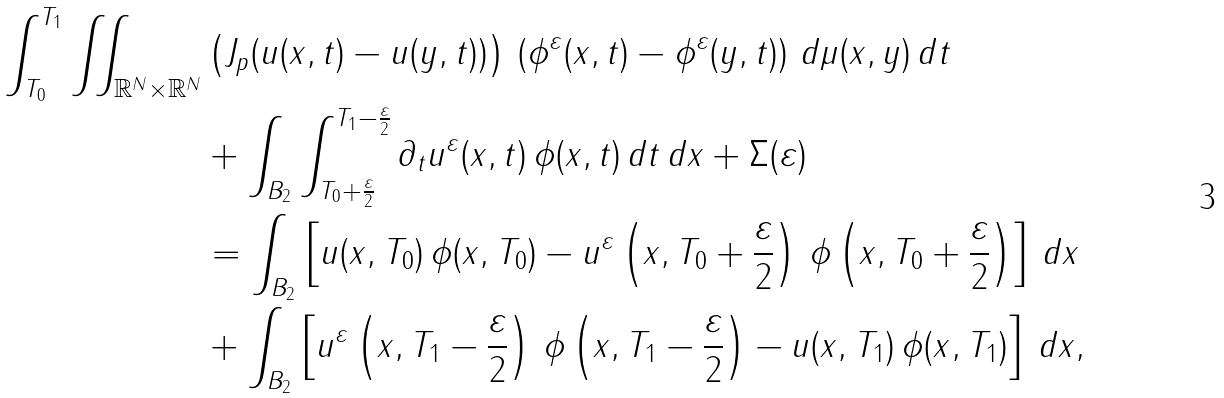<formula> <loc_0><loc_0><loc_500><loc_500>\int _ { T _ { 0 } } ^ { T _ { 1 } } \iint _ { \mathbb { R } ^ { N } \times \mathbb { R } ^ { N } } & \left ( J _ { p } ( u ( x , t ) - u ( y , t ) ) \right ) \, \left ( \phi ^ { \varepsilon } ( x , t ) - \phi ^ { \varepsilon } ( y , t ) \right ) \, d \mu ( x , y ) \, d t \\ & + \int _ { B _ { 2 } } \int _ { T _ { 0 } + \frac { \varepsilon } { 2 } } ^ { T _ { 1 } - \frac { \varepsilon } { 2 } } \partial _ { t } u ^ { \varepsilon } ( x , t ) \, \phi ( x , t ) \, d t \, d x + \Sigma ( \varepsilon ) \\ & = \int _ { B _ { 2 } } \left [ u ( x , T _ { 0 } ) \, \phi ( x , T _ { 0 } ) - u ^ { \varepsilon } \left ( x , T _ { 0 } + \frac { \varepsilon } { 2 } \right ) \, \phi \left ( x , T _ { 0 } + \frac { \varepsilon } { 2 } \right ) \right ] \, d x \\ & + \int _ { B _ { 2 } } \left [ u ^ { \varepsilon } \left ( x , T _ { 1 } - \frac { \varepsilon } { 2 } \right ) \, \phi \left ( x , T _ { 1 } - \frac { \varepsilon } { 2 } \right ) - u ( x , T _ { 1 } ) \, \phi ( x , T _ { 1 } ) \right ] \, d x ,</formula> 